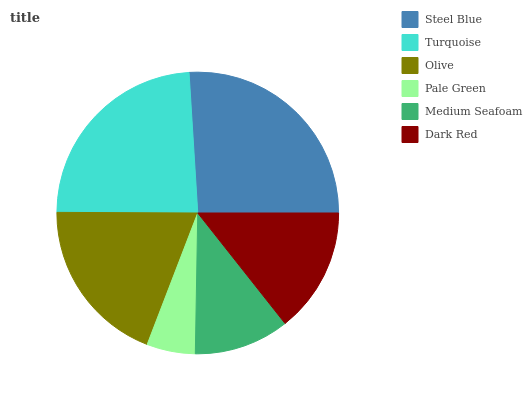Is Pale Green the minimum?
Answer yes or no. Yes. Is Steel Blue the maximum?
Answer yes or no. Yes. Is Turquoise the minimum?
Answer yes or no. No. Is Turquoise the maximum?
Answer yes or no. No. Is Steel Blue greater than Turquoise?
Answer yes or no. Yes. Is Turquoise less than Steel Blue?
Answer yes or no. Yes. Is Turquoise greater than Steel Blue?
Answer yes or no. No. Is Steel Blue less than Turquoise?
Answer yes or no. No. Is Olive the high median?
Answer yes or no. Yes. Is Dark Red the low median?
Answer yes or no. Yes. Is Dark Red the high median?
Answer yes or no. No. Is Pale Green the low median?
Answer yes or no. No. 